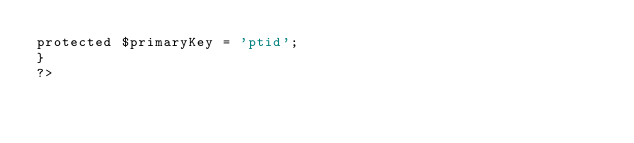Convert code to text. <code><loc_0><loc_0><loc_500><loc_500><_PHP_>protected $primaryKey = 'ptid';
}
?>
</code> 